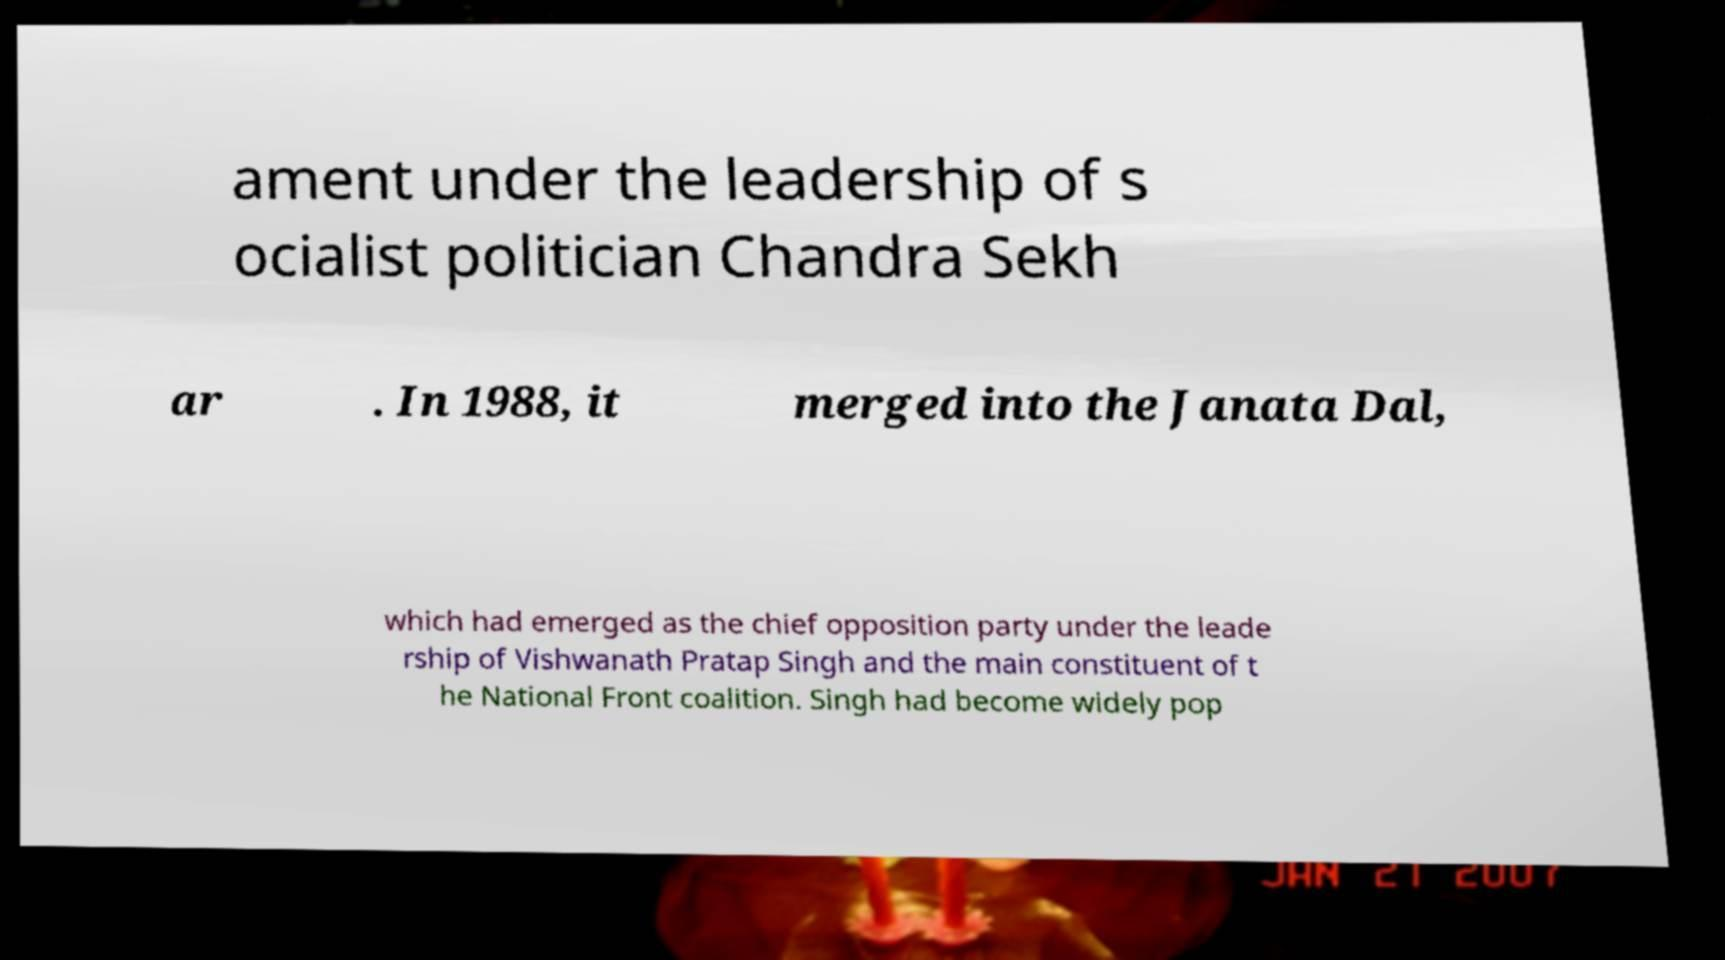I need the written content from this picture converted into text. Can you do that? ament under the leadership of s ocialist politician Chandra Sekh ar . In 1988, it merged into the Janata Dal, which had emerged as the chief opposition party under the leade rship of Vishwanath Pratap Singh and the main constituent of t he National Front coalition. Singh had become widely pop 